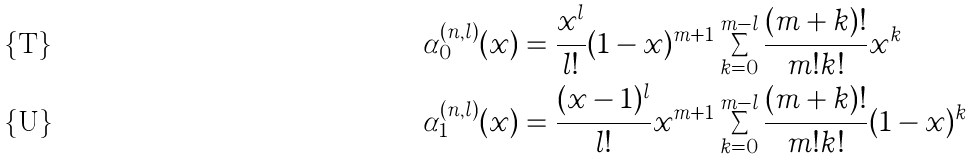Convert formula to latex. <formula><loc_0><loc_0><loc_500><loc_500>\alpha ^ { ( n , l ) } _ { 0 } ( x ) & = \frac { x ^ { l } } { l ! } ( 1 - x ) ^ { m + 1 } \sum _ { k = 0 } ^ { m - l } \frac { ( m + k ) ! } { m ! k ! } x ^ { k } \\ \alpha ^ { ( n , l ) } _ { 1 } ( x ) & = \frac { ( x - 1 ) ^ { l } } { l ! } x ^ { m + 1 } \sum _ { k = 0 } ^ { m - l } \frac { ( m + k ) ! } { m ! k ! } ( 1 - x ) ^ { k }</formula> 